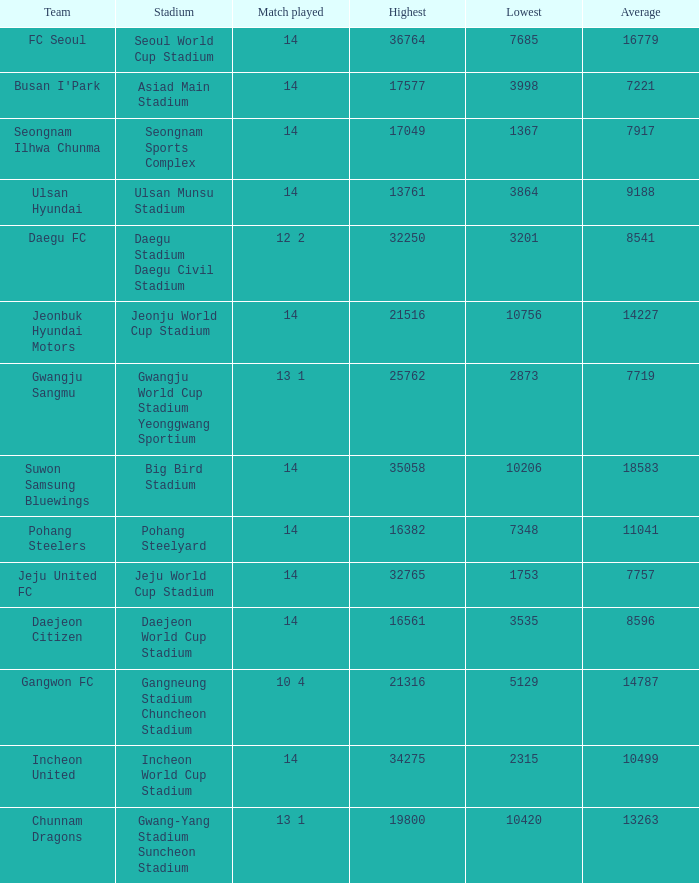How many match played have the highest as 32250? 12 2. 